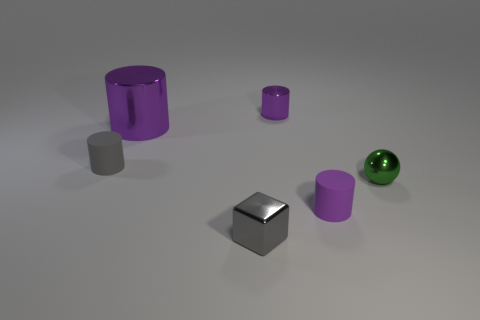Subtract all purple balls. How many purple cylinders are left? 3 Add 1 tiny blocks. How many objects exist? 7 Subtract all balls. How many objects are left? 5 Subtract all cubes. Subtract all tiny yellow metal things. How many objects are left? 5 Add 4 cubes. How many cubes are left? 5 Add 4 green shiny things. How many green shiny things exist? 5 Subtract 0 yellow cylinders. How many objects are left? 6 